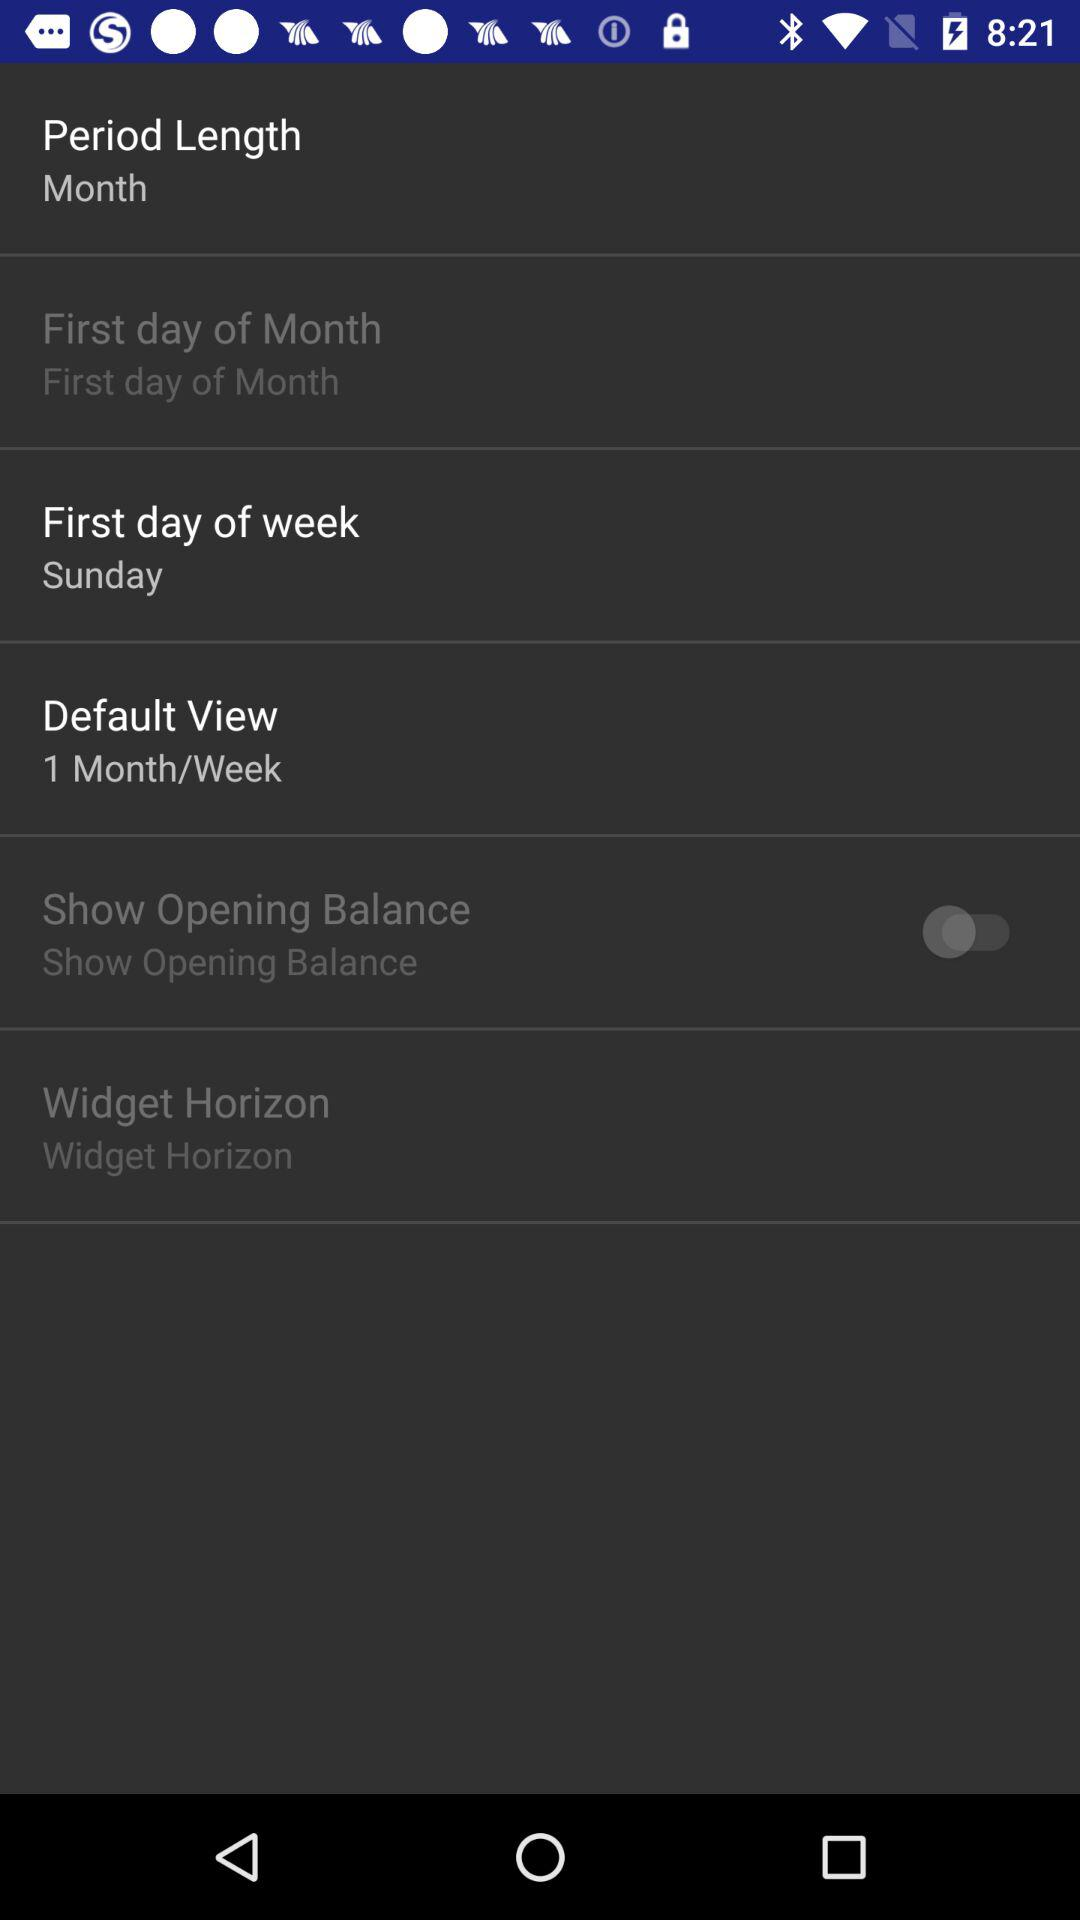What is the period length? The period length is a month. 